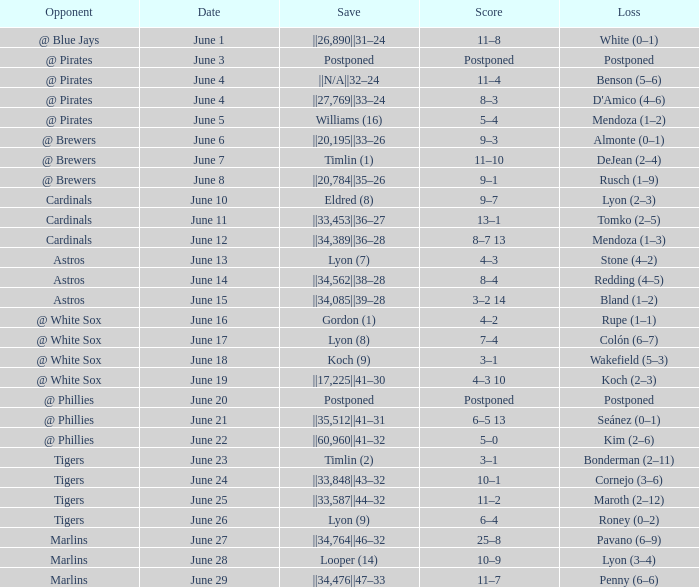Who is the opponent with a save of ||33,453||36–27? Cardinals. 